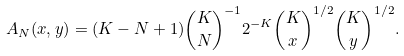Convert formula to latex. <formula><loc_0><loc_0><loc_500><loc_500>A _ { N } ( x , y ) = ( K - N + 1 ) \binom { K } { N } ^ { - 1 } 2 ^ { - K } \binom { K } { x } ^ { 1 / 2 } \binom { K } { y } ^ { 1 / 2 } .</formula> 